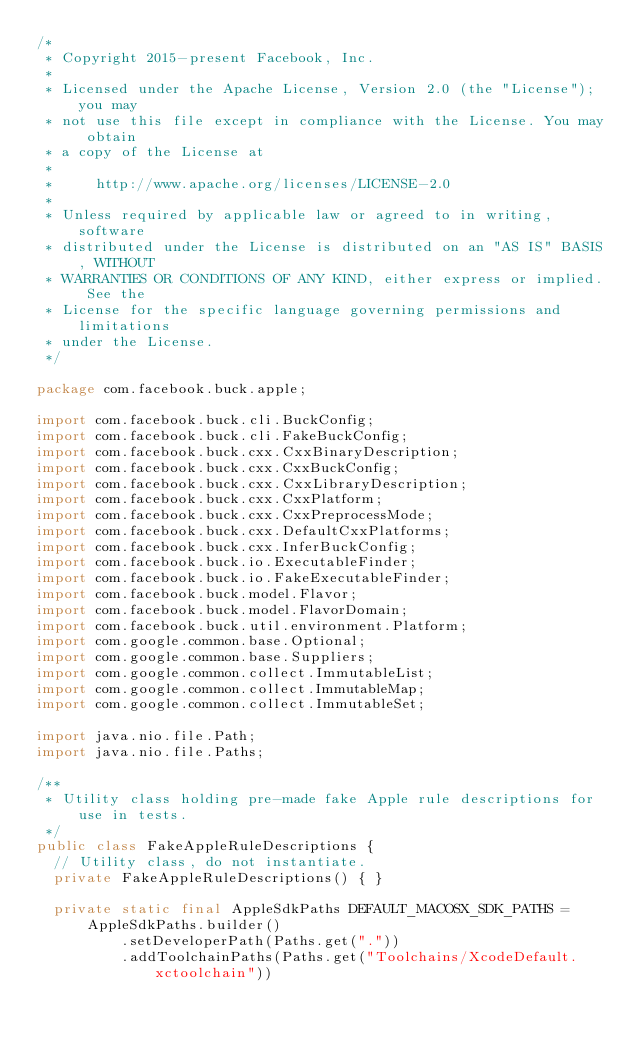Convert code to text. <code><loc_0><loc_0><loc_500><loc_500><_Java_>/*
 * Copyright 2015-present Facebook, Inc.
 *
 * Licensed under the Apache License, Version 2.0 (the "License"); you may
 * not use this file except in compliance with the License. You may obtain
 * a copy of the License at
 *
 *     http://www.apache.org/licenses/LICENSE-2.0
 *
 * Unless required by applicable law or agreed to in writing, software
 * distributed under the License is distributed on an "AS IS" BASIS, WITHOUT
 * WARRANTIES OR CONDITIONS OF ANY KIND, either express or implied. See the
 * License for the specific language governing permissions and limitations
 * under the License.
 */

package com.facebook.buck.apple;

import com.facebook.buck.cli.BuckConfig;
import com.facebook.buck.cli.FakeBuckConfig;
import com.facebook.buck.cxx.CxxBinaryDescription;
import com.facebook.buck.cxx.CxxBuckConfig;
import com.facebook.buck.cxx.CxxLibraryDescription;
import com.facebook.buck.cxx.CxxPlatform;
import com.facebook.buck.cxx.CxxPreprocessMode;
import com.facebook.buck.cxx.DefaultCxxPlatforms;
import com.facebook.buck.cxx.InferBuckConfig;
import com.facebook.buck.io.ExecutableFinder;
import com.facebook.buck.io.FakeExecutableFinder;
import com.facebook.buck.model.Flavor;
import com.facebook.buck.model.FlavorDomain;
import com.facebook.buck.util.environment.Platform;
import com.google.common.base.Optional;
import com.google.common.base.Suppliers;
import com.google.common.collect.ImmutableList;
import com.google.common.collect.ImmutableMap;
import com.google.common.collect.ImmutableSet;

import java.nio.file.Path;
import java.nio.file.Paths;

/**
 * Utility class holding pre-made fake Apple rule descriptions for use in tests.
 */
public class FakeAppleRuleDescriptions {
  // Utility class, do not instantiate.
  private FakeAppleRuleDescriptions() { }

  private static final AppleSdkPaths DEFAULT_MACOSX_SDK_PATHS =
      AppleSdkPaths.builder()
          .setDeveloperPath(Paths.get("."))
          .addToolchainPaths(Paths.get("Toolchains/XcodeDefault.xctoolchain"))</code> 